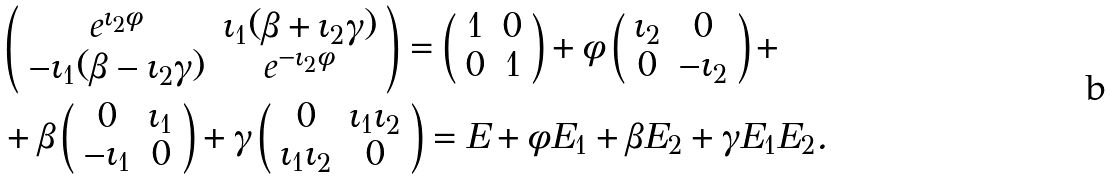Convert formula to latex. <formula><loc_0><loc_0><loc_500><loc_500>& \left ( \begin{array} { c c } e ^ { \iota _ { 2 } \phi } & \iota _ { 1 } ( \beta + \iota _ { 2 } \gamma ) \\ - \iota _ { 1 } ( \beta - \iota _ { 2 } \gamma ) & e ^ { - \iota _ { 2 } \phi } \end{array} \right ) = \left ( \begin{array} { c c } 1 & 0 \\ 0 & 1 \end{array} \right ) + \phi \left ( \begin{array} { c c } \iota _ { 2 } & 0 \\ 0 & - \iota _ { 2 } \end{array} \right ) + \\ & + \beta \left ( \begin{array} { c c } 0 & \iota _ { 1 } \\ - \iota _ { 1 } & 0 \end{array} \right ) + \gamma \left ( \begin{array} { c c } 0 & \iota _ { 1 } \iota _ { 2 } \\ \iota _ { 1 } \iota _ { 2 } & 0 \end{array} \right ) = E + \phi E _ { 1 } + \beta E _ { 2 } + \gamma E _ { 1 } E _ { 2 } .</formula> 